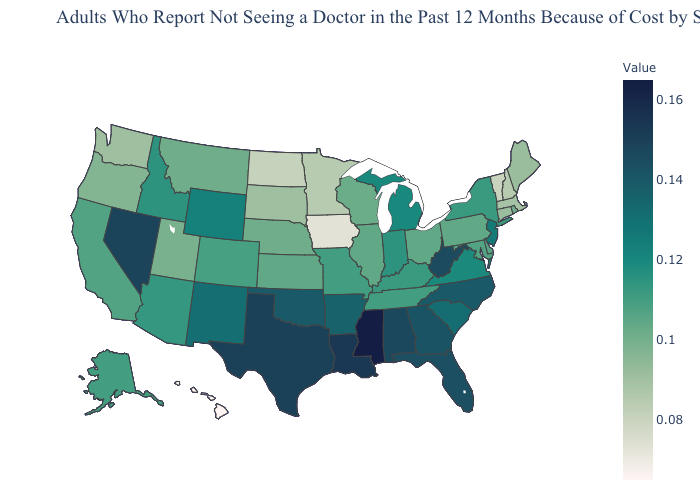Among the states that border Montana , which have the highest value?
Give a very brief answer. Wyoming. Does Ohio have a higher value than Vermont?
Keep it brief. Yes. Does Washington have the highest value in the USA?
Short answer required. No. Does Mississippi have the highest value in the USA?
Answer briefly. Yes. Does Nevada have a lower value than Mississippi?
Be succinct. Yes. Does Iowa have a lower value than Utah?
Quick response, please. Yes. 